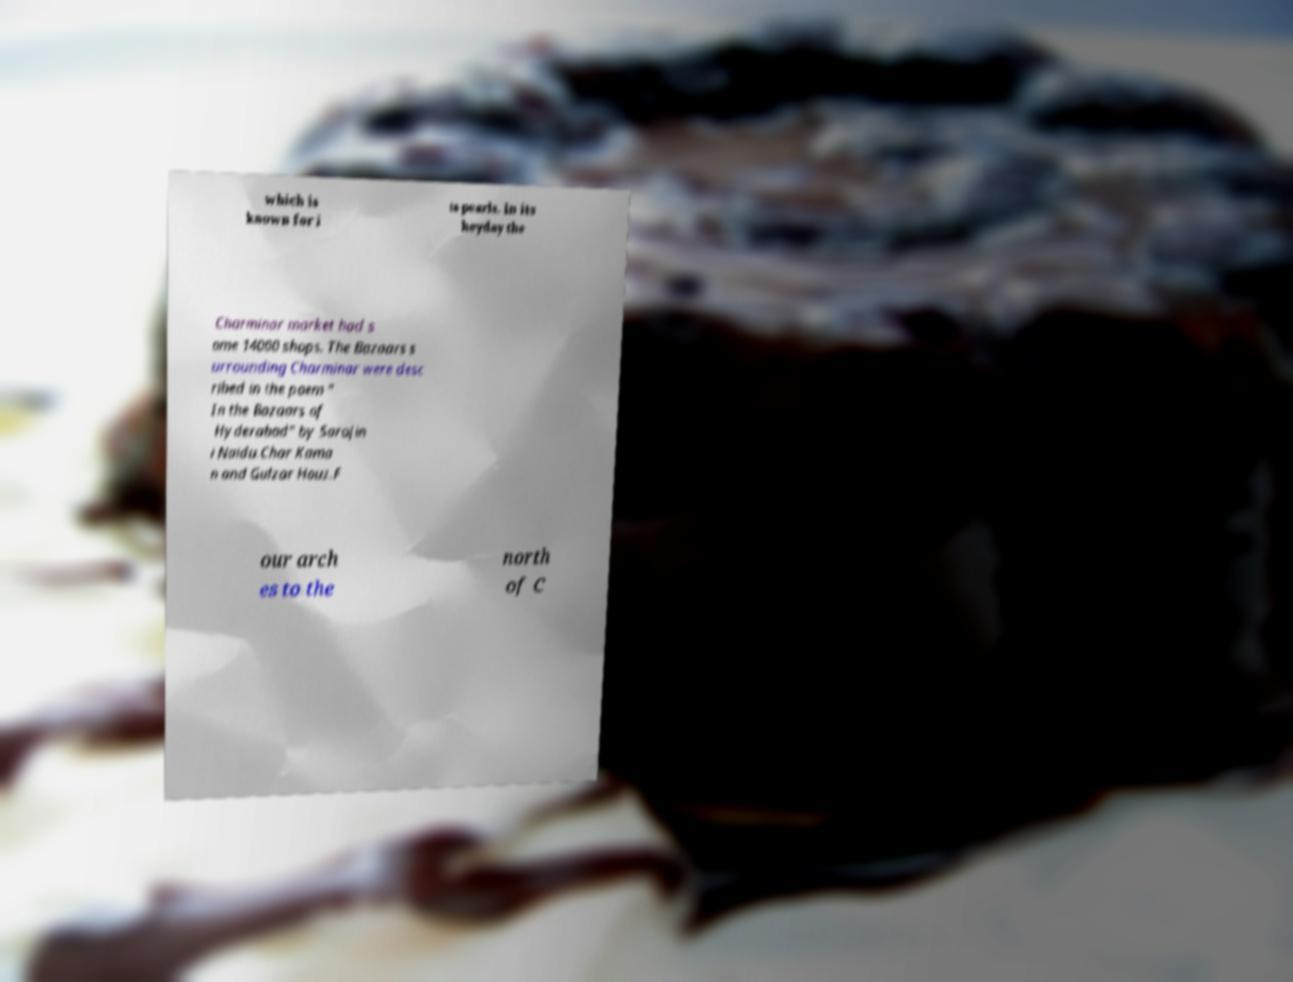What messages or text are displayed in this image? I need them in a readable, typed format. which is known for i ts pearls. In its heyday the Charminar market had s ome 14000 shops. The Bazaars s urrounding Charminar were desc ribed in the poem " In the Bazaars of Hyderabad" by Sarojin i Naidu.Char Kama n and Gulzar Houz.F our arch es to the north of C 